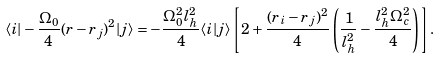<formula> <loc_0><loc_0><loc_500><loc_500>\langle i | - \frac { \Omega _ { 0 } } { 4 } ( r - r _ { j } ) ^ { 2 } | j \rangle = - \frac { \Omega _ { 0 } ^ { 2 } l _ { h } ^ { 2 } } { 4 } \langle i | j \rangle \left [ 2 + \frac { ( r _ { i } - r _ { j } ) ^ { 2 } } { 4 } \left ( \frac { 1 } { l _ { h } ^ { 2 } } - \frac { l _ { h } ^ { 2 } \Omega _ { c } ^ { 2 } } { 4 } \right ) \right ] .</formula> 